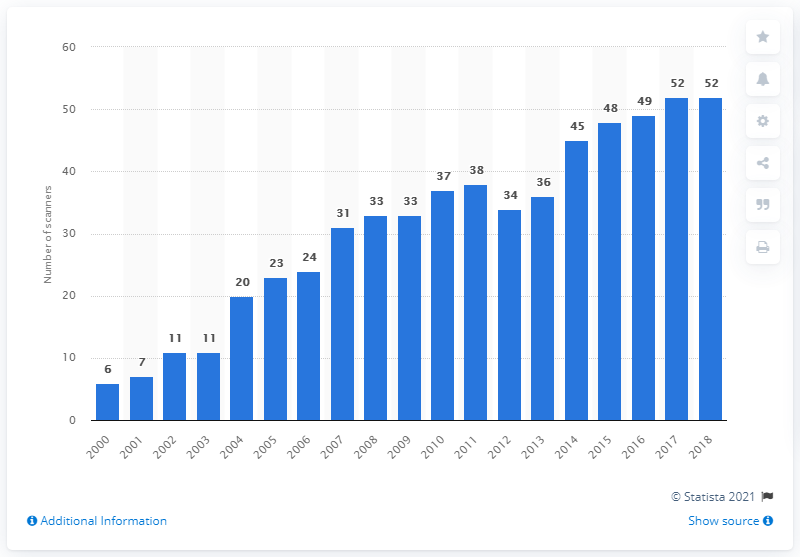Outline some significant characteristics in this image. In 2018, there were 52 MRI scanners in Slovakia. 